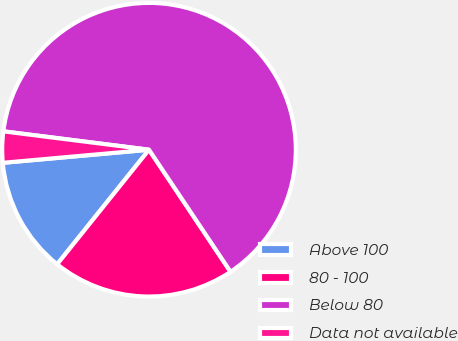Convert chart. <chart><loc_0><loc_0><loc_500><loc_500><pie_chart><fcel>Above 100<fcel>80 - 100<fcel>Below 80<fcel>Data not available<nl><fcel>12.82%<fcel>20.13%<fcel>63.63%<fcel>3.42%<nl></chart> 